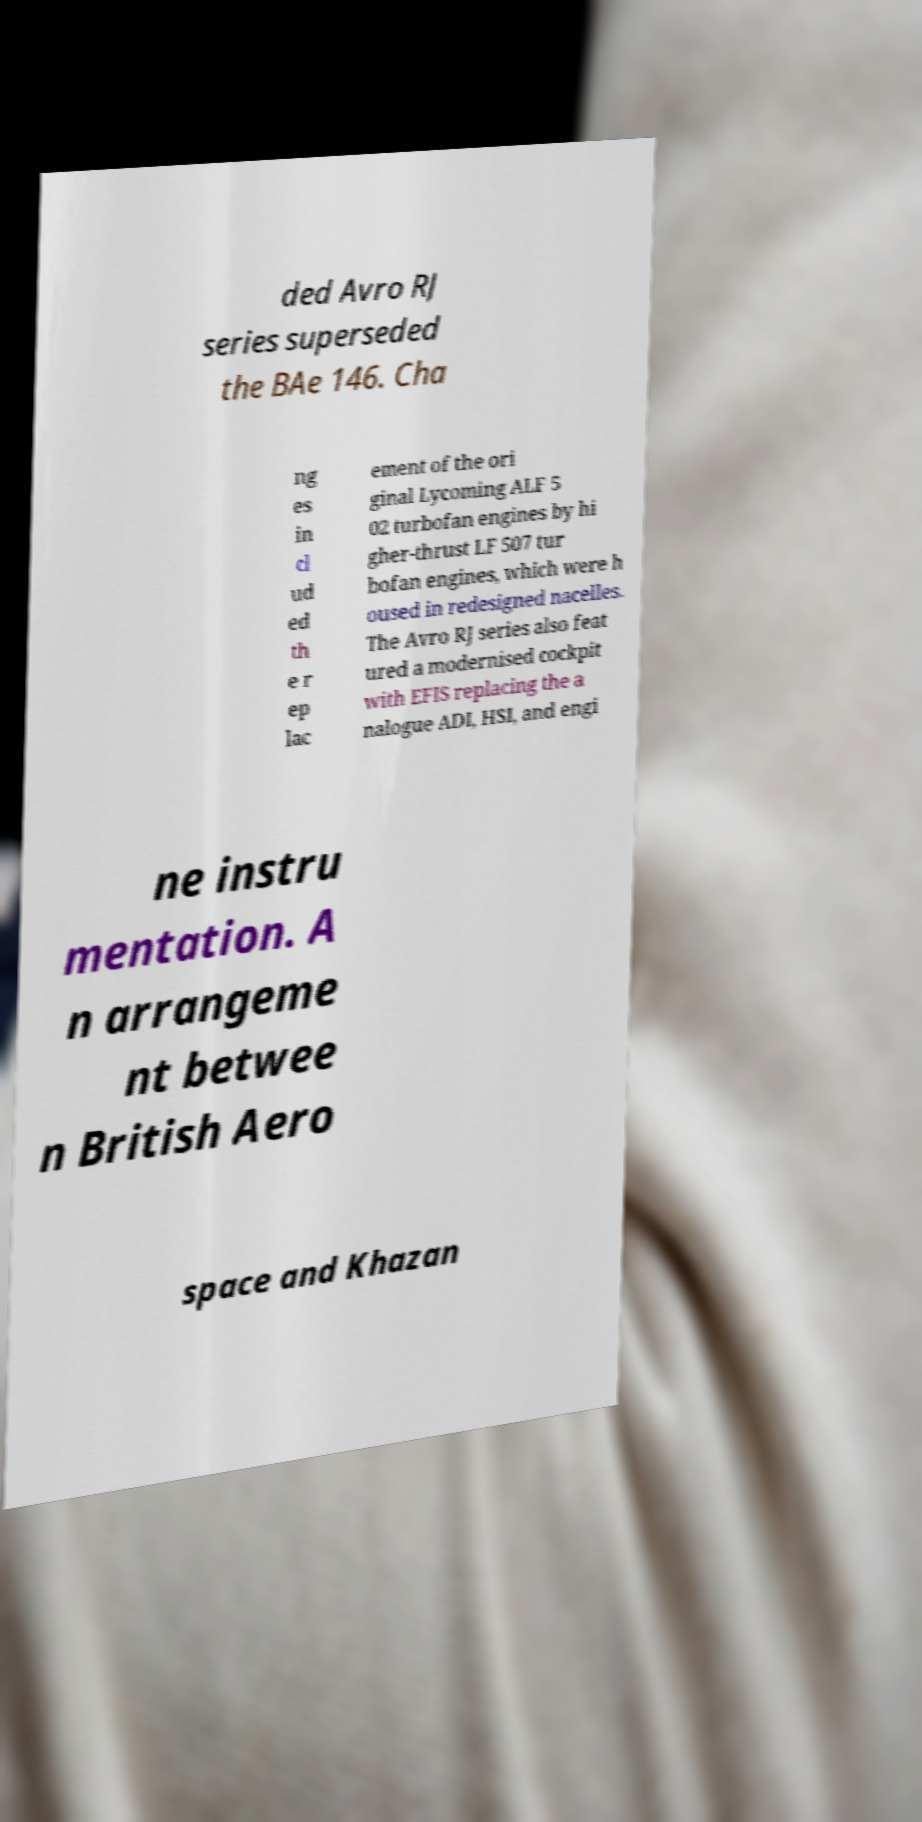Can you read and provide the text displayed in the image?This photo seems to have some interesting text. Can you extract and type it out for me? ded Avro RJ series superseded the BAe 146. Cha ng es in cl ud ed th e r ep lac ement of the ori ginal Lycoming ALF 5 02 turbofan engines by hi gher-thrust LF 507 tur bofan engines, which were h oused in redesigned nacelles. The Avro RJ series also feat ured a modernised cockpit with EFIS replacing the a nalogue ADI, HSI, and engi ne instru mentation. A n arrangeme nt betwee n British Aero space and Khazan 